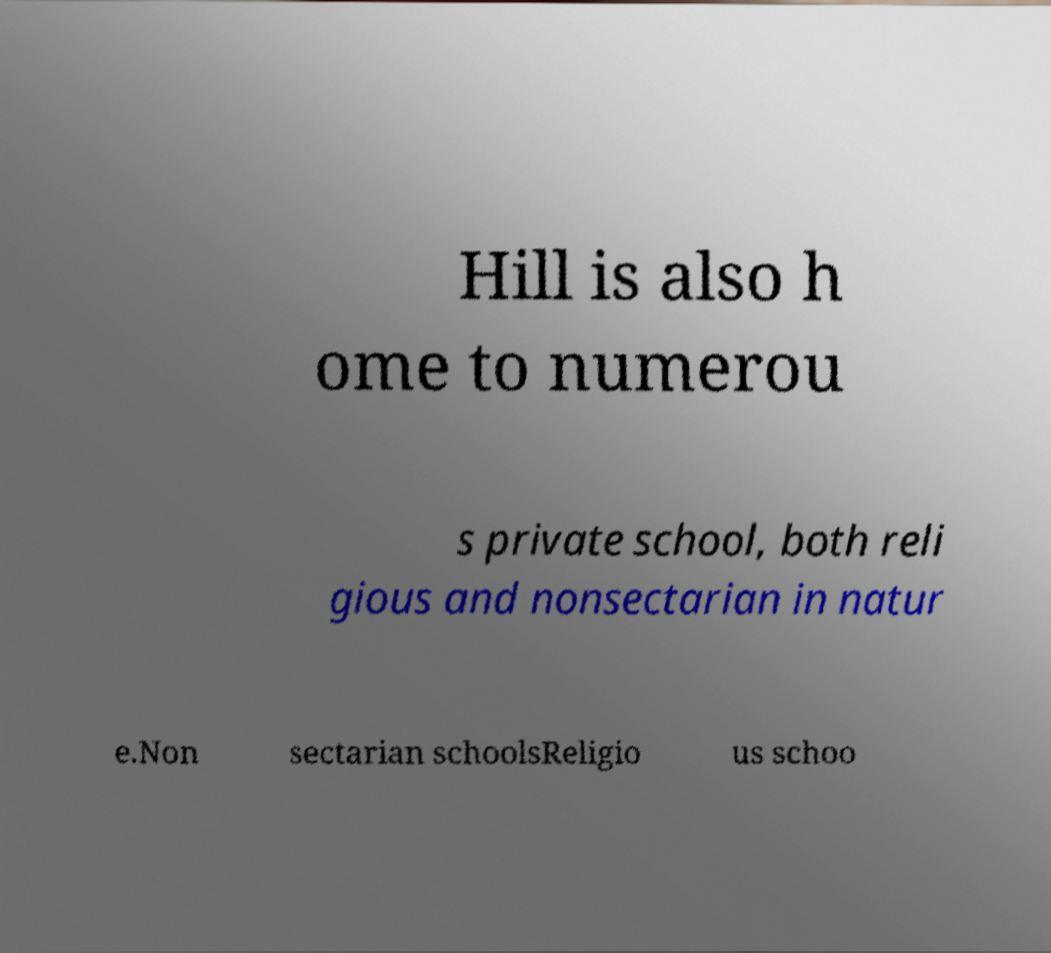Could you extract and type out the text from this image? Hill is also h ome to numerou s private school, both reli gious and nonsectarian in natur e.Non sectarian schoolsReligio us schoo 